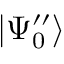<formula> <loc_0><loc_0><loc_500><loc_500>| \Psi _ { 0 } ^ { \prime \prime } \rangle</formula> 